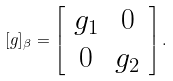<formula> <loc_0><loc_0><loc_500><loc_500>[ g ] _ { \beta } = \left [ \begin{array} { c c } g _ { 1 } & 0 \\ 0 & g _ { 2 } \end{array} \right ] .</formula> 